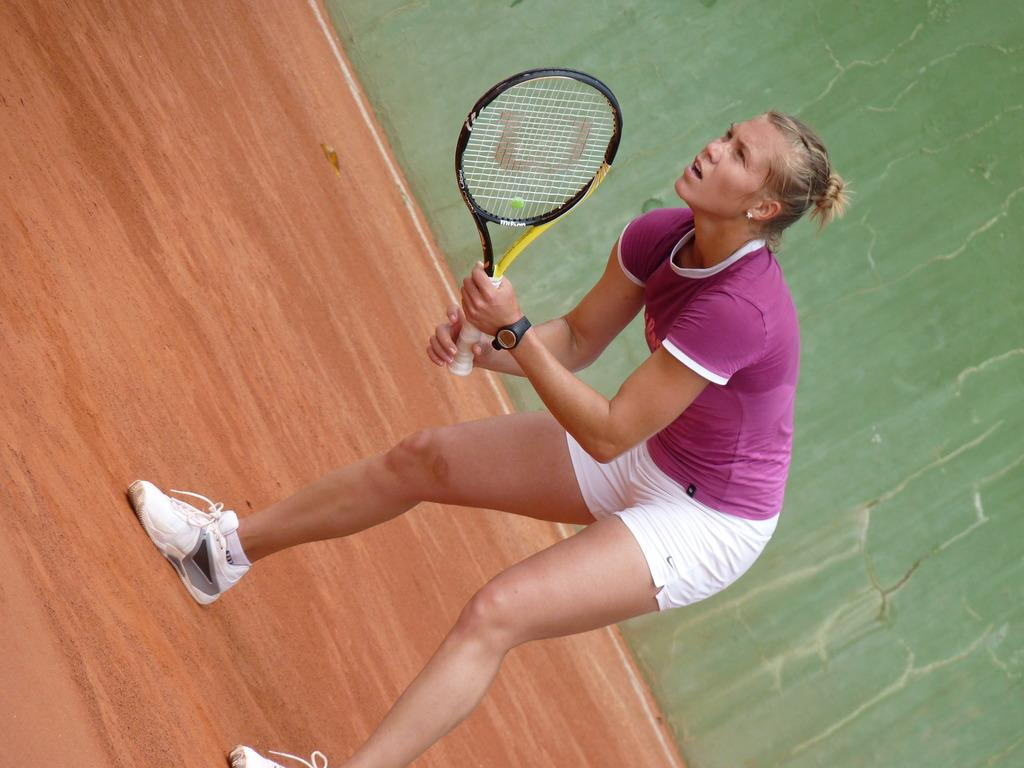Who is the main subject in the image? There is a woman in the image. Where is the woman positioned in the image? The woman is standing in the middle of the image. What is the woman holding in the image? The woman is holding a tennis racket. What can be seen behind the woman in the image? There is a wall behind the woman. What type of industry is depicted in the image? There is no industry depicted in the image; it features a woman holding a tennis racket. How many unmentioned objects are present in the image? It is not possible to determine the number of unmentioned objects in the image based on the provided facts. 